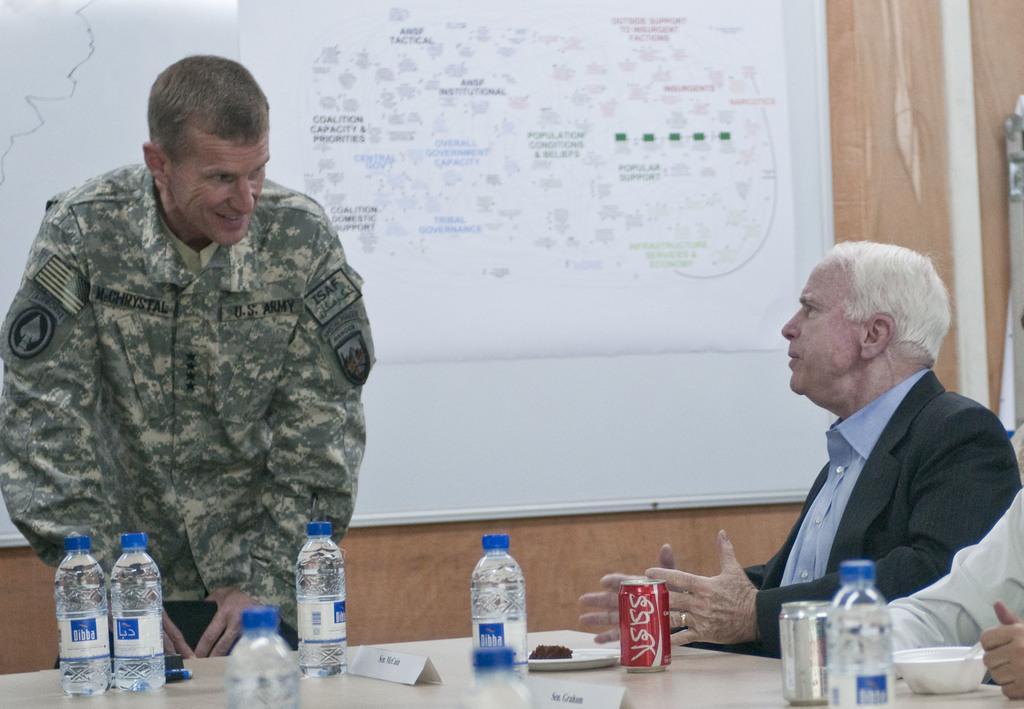How would you summarize this image in a sentence or two? This is the man standing and holding the chair,and another man sitting and talking. This is the table with water bottles,tins,plate and name boards on it. At the right side of the image I can see another person hand. This is the poster attached to the wall. 